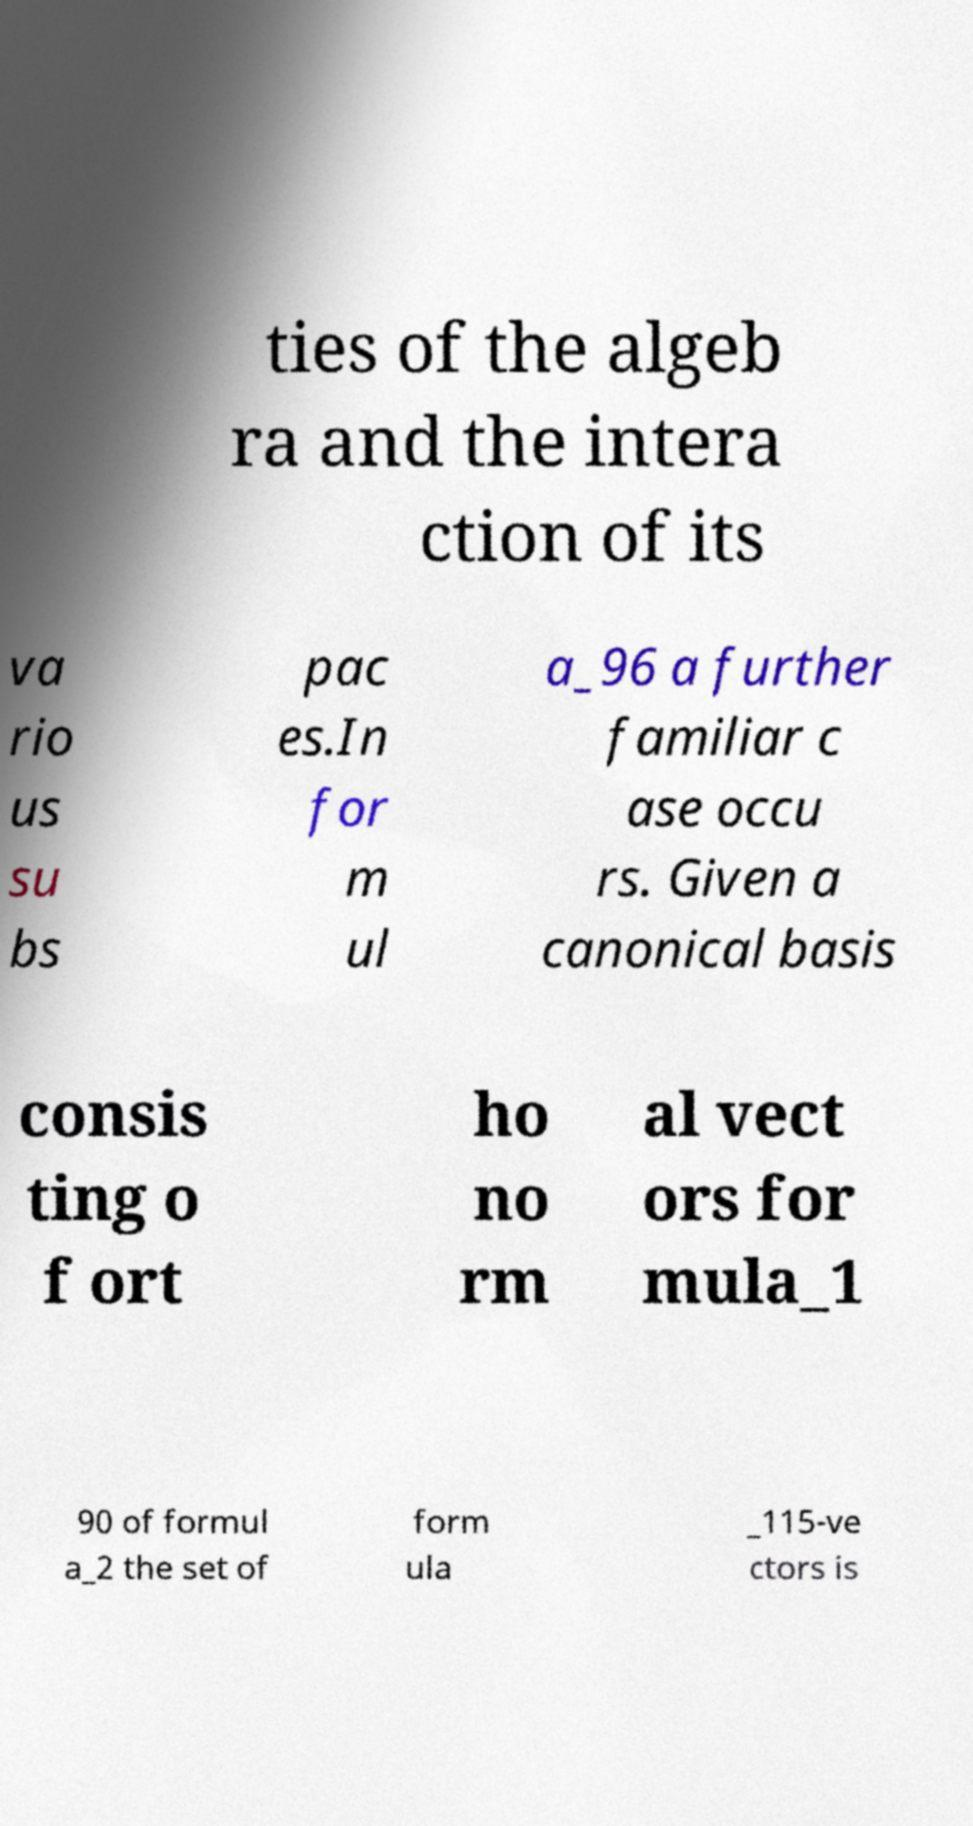Can you accurately transcribe the text from the provided image for me? ties of the algeb ra and the intera ction of its va rio us su bs pac es.In for m ul a_96 a further familiar c ase occu rs. Given a canonical basis consis ting o f ort ho no rm al vect ors for mula_1 90 of formul a_2 the set of form ula _115-ve ctors is 